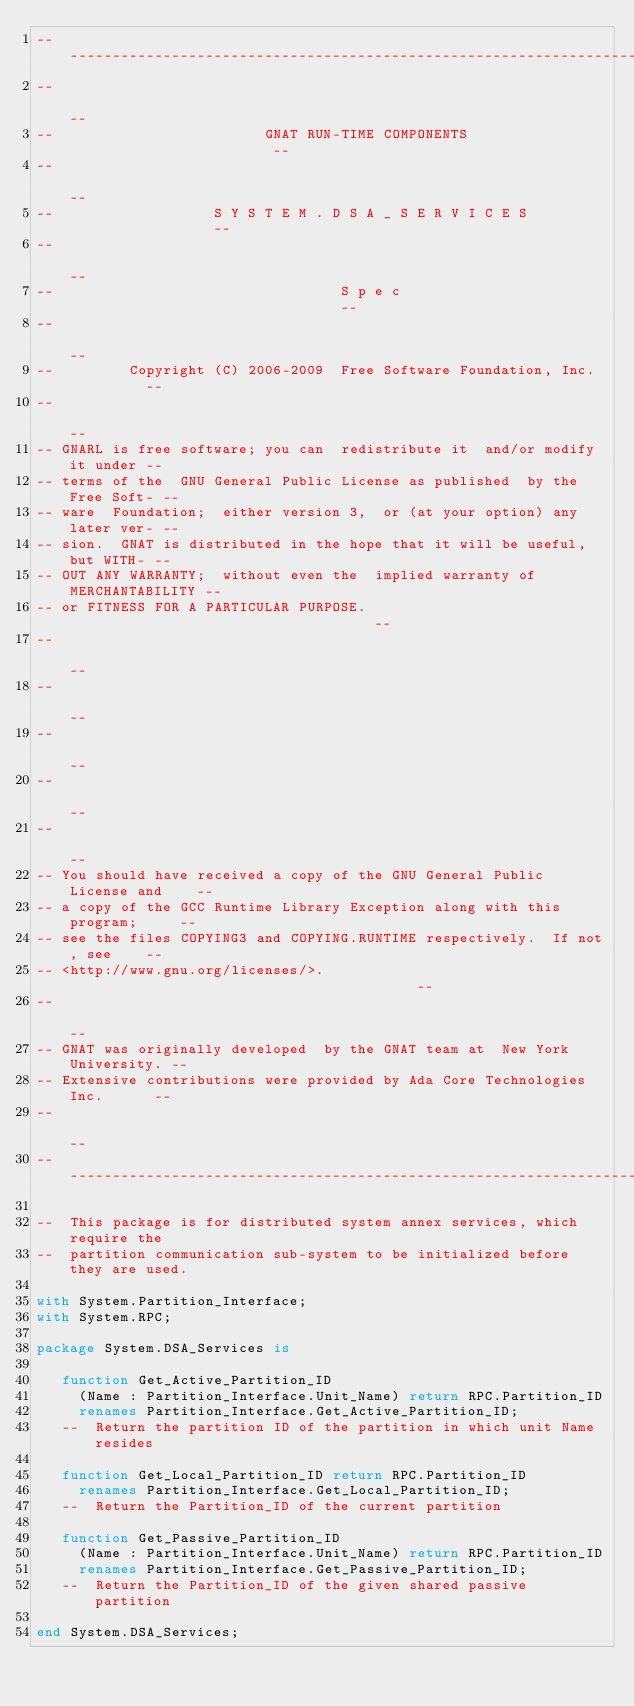<code> <loc_0><loc_0><loc_500><loc_500><_Ada_>------------------------------------------------------------------------------
--                                                                          --
--                         GNAT RUN-TIME COMPONENTS                         --
--                                                                          --
--                   S Y S T E M . D S A _ S E R V I C E S                  --
--                                                                          --
--                                  S p e c                                 --
--                                                                          --
--         Copyright (C) 2006-2009  Free Software Foundation, Inc.          --
--                                                                          --
-- GNARL is free software; you can  redistribute it  and/or modify it under --
-- terms of the  GNU General Public License as published  by the Free Soft- --
-- ware  Foundation;  either version 3,  or (at your option) any later ver- --
-- sion.  GNAT is distributed in the hope that it will be useful, but WITH- --
-- OUT ANY WARRANTY;  without even the  implied warranty of MERCHANTABILITY --
-- or FITNESS FOR A PARTICULAR PURPOSE.                                     --
--                                                                          --
--                                                                          --
--                                                                          --
--                                                                          --
--                                                                          --
-- You should have received a copy of the GNU General Public License and    --
-- a copy of the GCC Runtime Library Exception along with this program;     --
-- see the files COPYING3 and COPYING.RUNTIME respectively.  If not, see    --
-- <http://www.gnu.org/licenses/>.                                          --
--                                                                          --
-- GNAT was originally developed  by the GNAT team at  New York University. --
-- Extensive contributions were provided by Ada Core Technologies Inc.      --
--                                                                          --
------------------------------------------------------------------------------

--  This package is for distributed system annex services, which require the
--  partition communication sub-system to be initialized before they are used.

with System.Partition_Interface;
with System.RPC;

package System.DSA_Services is

   function Get_Active_Partition_ID
     (Name : Partition_Interface.Unit_Name) return RPC.Partition_ID
     renames Partition_Interface.Get_Active_Partition_ID;
   --  Return the partition ID of the partition in which unit Name resides

   function Get_Local_Partition_ID return RPC.Partition_ID
     renames Partition_Interface.Get_Local_Partition_ID;
   --  Return the Partition_ID of the current partition

   function Get_Passive_Partition_ID
     (Name : Partition_Interface.Unit_Name) return RPC.Partition_ID
     renames Partition_Interface.Get_Passive_Partition_ID;
   --  Return the Partition_ID of the given shared passive partition

end System.DSA_Services;
</code> 